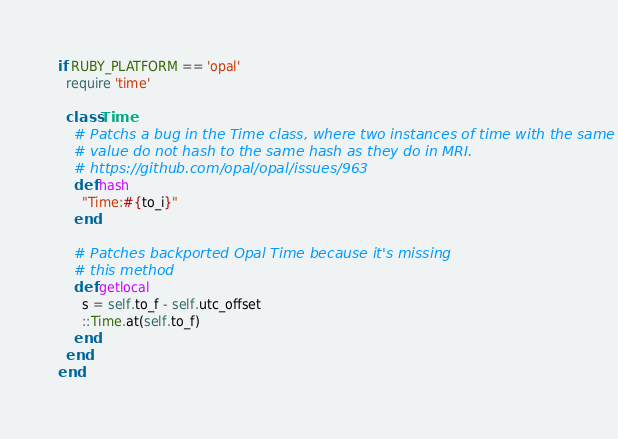Convert code to text. <code><loc_0><loc_0><loc_500><loc_500><_Ruby_>if RUBY_PLATFORM == 'opal'
  require 'time'

  class Time
    # Patchs a bug in the Time class, where two instances of time with the same
    # value do not hash to the same hash as they do in MRI.
    # https://github.com/opal/opal/issues/963
    def hash
      "Time:#{to_i}"
    end
   
    # Patches backported Opal Time because it's missing
    # this method 
    def getlocal  
      s = self.to_f - self.utc_offset
      ::Time.at(self.to_f)
    end
  end
end
</code> 